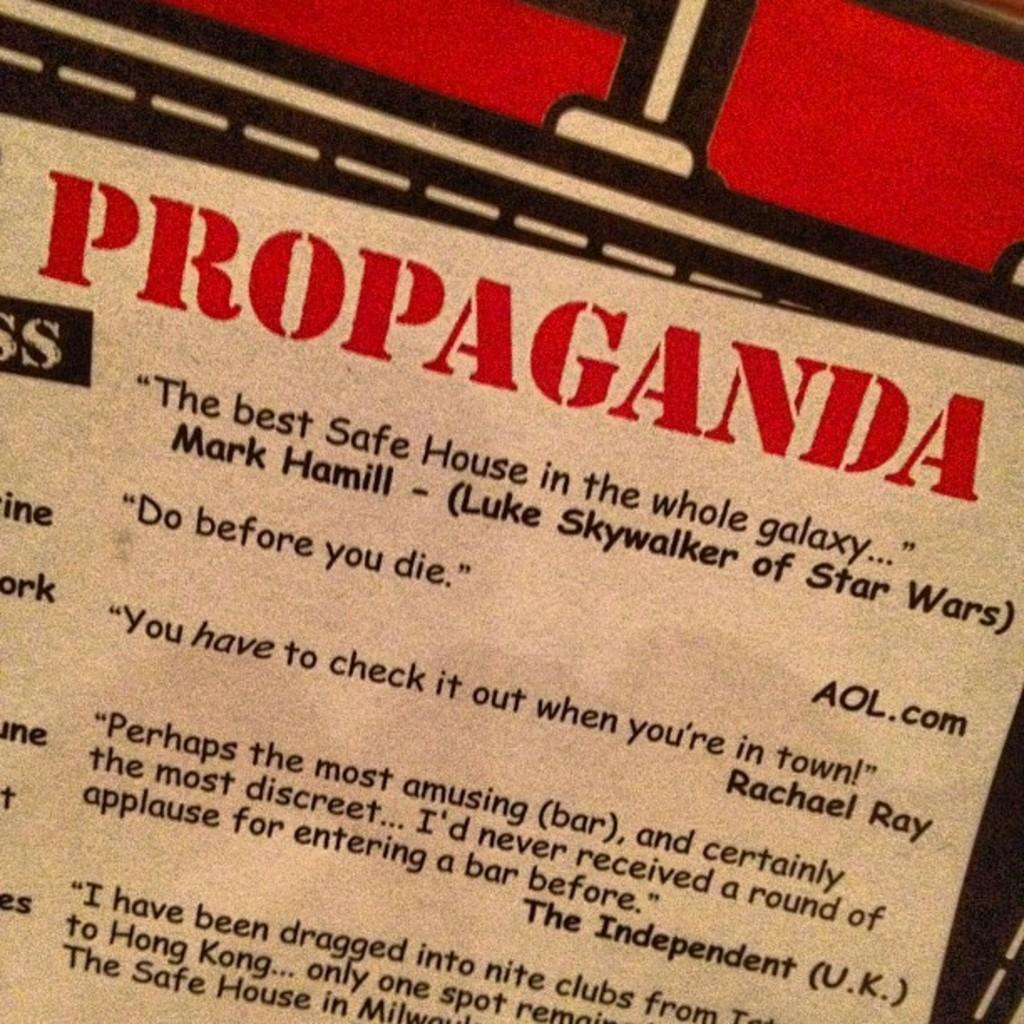<image>
Offer a succinct explanation of the picture presented. A proaganda poster featuring quotes by Mark Hamill and Rachael Ray among others. 